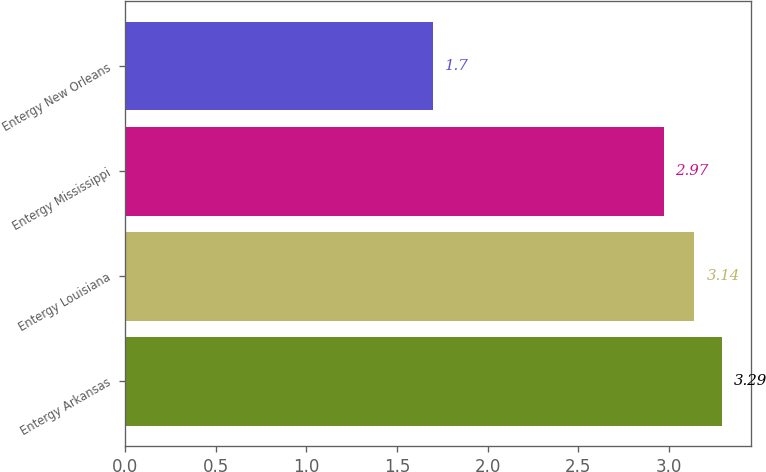<chart> <loc_0><loc_0><loc_500><loc_500><bar_chart><fcel>Entergy Arkansas<fcel>Entergy Louisiana<fcel>Entergy Mississippi<fcel>Entergy New Orleans<nl><fcel>3.29<fcel>3.14<fcel>2.97<fcel>1.7<nl></chart> 